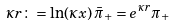<formula> <loc_0><loc_0><loc_500><loc_500>\kappa r \colon = \ln ( \kappa x ) \, { \bar { \pi } } _ { + } = e ^ { \kappa r } \pi _ { + }</formula> 